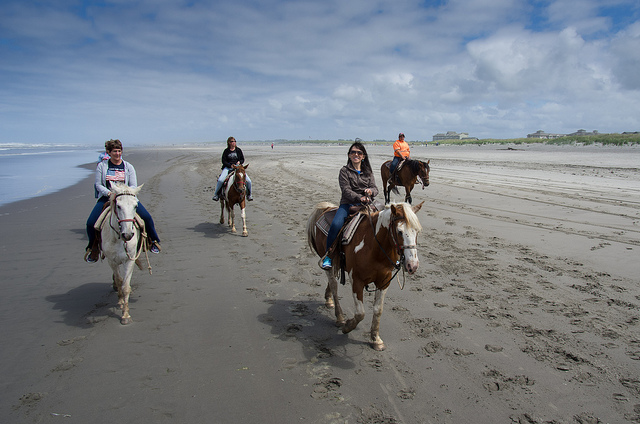<image>Are the horses a male or female? I don't know if the horses are male or female. It could be either, both or be unknown. Are the horses a male or female? I don't know if the horses are male or female. They can be both male and female. 